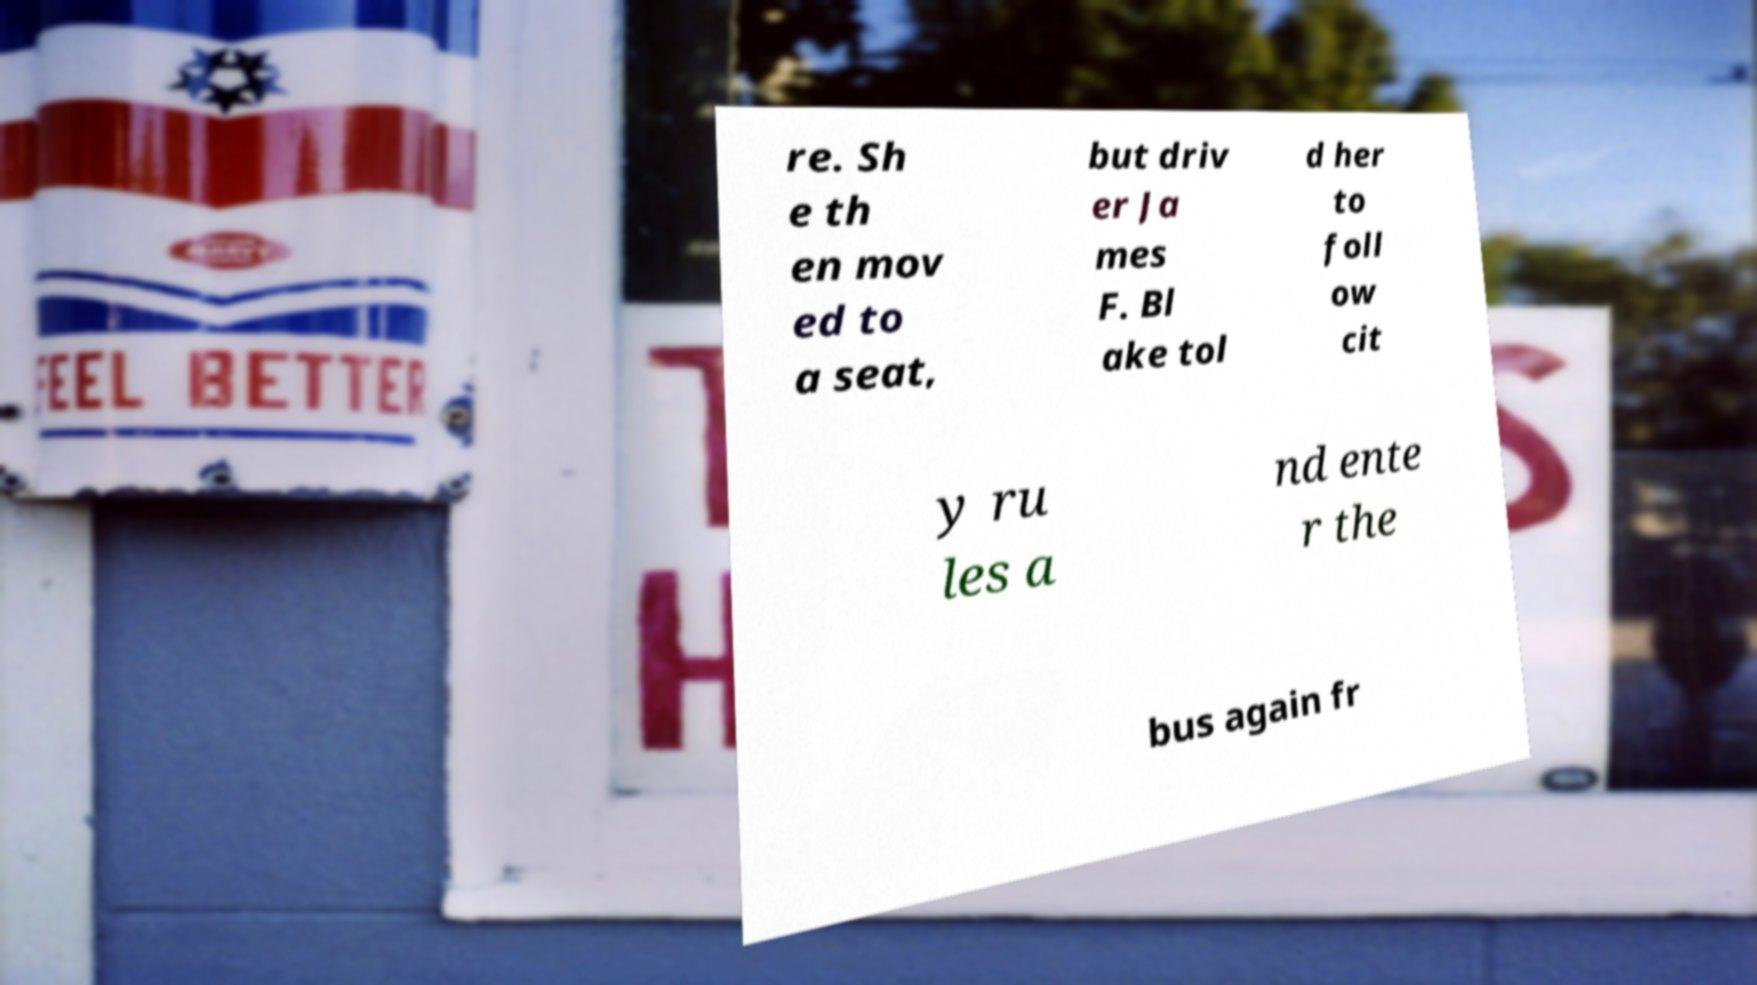For documentation purposes, I need the text within this image transcribed. Could you provide that? re. Sh e th en mov ed to a seat, but driv er Ja mes F. Bl ake tol d her to foll ow cit y ru les a nd ente r the bus again fr 